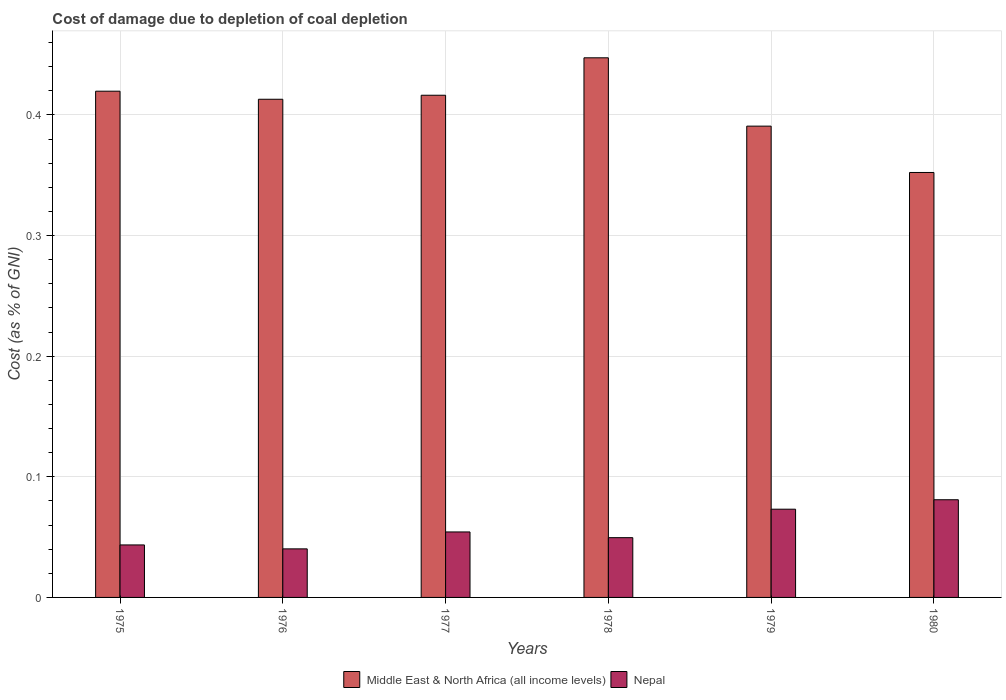Are the number of bars on each tick of the X-axis equal?
Your response must be concise. Yes. How many bars are there on the 3rd tick from the right?
Make the answer very short. 2. What is the label of the 2nd group of bars from the left?
Your answer should be very brief. 1976. What is the cost of damage caused due to coal depletion in Nepal in 1978?
Give a very brief answer. 0.05. Across all years, what is the maximum cost of damage caused due to coal depletion in Middle East & North Africa (all income levels)?
Keep it short and to the point. 0.45. Across all years, what is the minimum cost of damage caused due to coal depletion in Middle East & North Africa (all income levels)?
Your answer should be compact. 0.35. In which year was the cost of damage caused due to coal depletion in Middle East & North Africa (all income levels) maximum?
Ensure brevity in your answer.  1978. What is the total cost of damage caused due to coal depletion in Nepal in the graph?
Provide a short and direct response. 0.34. What is the difference between the cost of damage caused due to coal depletion in Middle East & North Africa (all income levels) in 1978 and that in 1979?
Ensure brevity in your answer.  0.06. What is the difference between the cost of damage caused due to coal depletion in Nepal in 1975 and the cost of damage caused due to coal depletion in Middle East & North Africa (all income levels) in 1978?
Your answer should be very brief. -0.4. What is the average cost of damage caused due to coal depletion in Nepal per year?
Your answer should be very brief. 0.06. In the year 1979, what is the difference between the cost of damage caused due to coal depletion in Middle East & North Africa (all income levels) and cost of damage caused due to coal depletion in Nepal?
Your response must be concise. 0.32. In how many years, is the cost of damage caused due to coal depletion in Middle East & North Africa (all income levels) greater than 0.24000000000000002 %?
Your answer should be very brief. 6. What is the ratio of the cost of damage caused due to coal depletion in Middle East & North Africa (all income levels) in 1975 to that in 1980?
Your answer should be very brief. 1.19. Is the cost of damage caused due to coal depletion in Nepal in 1976 less than that in 1977?
Your answer should be compact. Yes. Is the difference between the cost of damage caused due to coal depletion in Middle East & North Africa (all income levels) in 1977 and 1980 greater than the difference between the cost of damage caused due to coal depletion in Nepal in 1977 and 1980?
Provide a short and direct response. Yes. What is the difference between the highest and the second highest cost of damage caused due to coal depletion in Middle East & North Africa (all income levels)?
Give a very brief answer. 0.03. What is the difference between the highest and the lowest cost of damage caused due to coal depletion in Nepal?
Keep it short and to the point. 0.04. Is the sum of the cost of damage caused due to coal depletion in Middle East & North Africa (all income levels) in 1976 and 1978 greater than the maximum cost of damage caused due to coal depletion in Nepal across all years?
Offer a terse response. Yes. What does the 1st bar from the left in 1977 represents?
Make the answer very short. Middle East & North Africa (all income levels). What does the 1st bar from the right in 1977 represents?
Provide a short and direct response. Nepal. How many bars are there?
Your answer should be very brief. 12. Are all the bars in the graph horizontal?
Make the answer very short. No. How many years are there in the graph?
Ensure brevity in your answer.  6. Does the graph contain any zero values?
Your answer should be compact. No. Where does the legend appear in the graph?
Your answer should be very brief. Bottom center. How many legend labels are there?
Offer a terse response. 2. How are the legend labels stacked?
Offer a very short reply. Horizontal. What is the title of the graph?
Keep it short and to the point. Cost of damage due to depletion of coal depletion. What is the label or title of the X-axis?
Keep it short and to the point. Years. What is the label or title of the Y-axis?
Offer a terse response. Cost (as % of GNI). What is the Cost (as % of GNI) of Middle East & North Africa (all income levels) in 1975?
Give a very brief answer. 0.42. What is the Cost (as % of GNI) of Nepal in 1975?
Your answer should be very brief. 0.04. What is the Cost (as % of GNI) in Middle East & North Africa (all income levels) in 1976?
Your response must be concise. 0.41. What is the Cost (as % of GNI) in Nepal in 1976?
Your answer should be compact. 0.04. What is the Cost (as % of GNI) of Middle East & North Africa (all income levels) in 1977?
Your response must be concise. 0.42. What is the Cost (as % of GNI) of Nepal in 1977?
Give a very brief answer. 0.05. What is the Cost (as % of GNI) in Middle East & North Africa (all income levels) in 1978?
Your response must be concise. 0.45. What is the Cost (as % of GNI) in Nepal in 1978?
Offer a terse response. 0.05. What is the Cost (as % of GNI) of Middle East & North Africa (all income levels) in 1979?
Give a very brief answer. 0.39. What is the Cost (as % of GNI) of Nepal in 1979?
Offer a terse response. 0.07. What is the Cost (as % of GNI) of Middle East & North Africa (all income levels) in 1980?
Your response must be concise. 0.35. What is the Cost (as % of GNI) in Nepal in 1980?
Give a very brief answer. 0.08. Across all years, what is the maximum Cost (as % of GNI) of Middle East & North Africa (all income levels)?
Give a very brief answer. 0.45. Across all years, what is the maximum Cost (as % of GNI) of Nepal?
Provide a succinct answer. 0.08. Across all years, what is the minimum Cost (as % of GNI) in Middle East & North Africa (all income levels)?
Provide a short and direct response. 0.35. Across all years, what is the minimum Cost (as % of GNI) of Nepal?
Provide a short and direct response. 0.04. What is the total Cost (as % of GNI) in Middle East & North Africa (all income levels) in the graph?
Make the answer very short. 2.44. What is the total Cost (as % of GNI) in Nepal in the graph?
Your response must be concise. 0.34. What is the difference between the Cost (as % of GNI) of Middle East & North Africa (all income levels) in 1975 and that in 1976?
Give a very brief answer. 0.01. What is the difference between the Cost (as % of GNI) of Nepal in 1975 and that in 1976?
Give a very brief answer. 0. What is the difference between the Cost (as % of GNI) in Middle East & North Africa (all income levels) in 1975 and that in 1977?
Your answer should be compact. 0. What is the difference between the Cost (as % of GNI) in Nepal in 1975 and that in 1977?
Your response must be concise. -0.01. What is the difference between the Cost (as % of GNI) of Middle East & North Africa (all income levels) in 1975 and that in 1978?
Offer a terse response. -0.03. What is the difference between the Cost (as % of GNI) of Nepal in 1975 and that in 1978?
Offer a terse response. -0.01. What is the difference between the Cost (as % of GNI) in Middle East & North Africa (all income levels) in 1975 and that in 1979?
Your answer should be very brief. 0.03. What is the difference between the Cost (as % of GNI) in Nepal in 1975 and that in 1979?
Make the answer very short. -0.03. What is the difference between the Cost (as % of GNI) in Middle East & North Africa (all income levels) in 1975 and that in 1980?
Provide a succinct answer. 0.07. What is the difference between the Cost (as % of GNI) in Nepal in 1975 and that in 1980?
Your response must be concise. -0.04. What is the difference between the Cost (as % of GNI) of Middle East & North Africa (all income levels) in 1976 and that in 1977?
Ensure brevity in your answer.  -0. What is the difference between the Cost (as % of GNI) in Nepal in 1976 and that in 1977?
Provide a short and direct response. -0.01. What is the difference between the Cost (as % of GNI) of Middle East & North Africa (all income levels) in 1976 and that in 1978?
Ensure brevity in your answer.  -0.03. What is the difference between the Cost (as % of GNI) of Nepal in 1976 and that in 1978?
Give a very brief answer. -0.01. What is the difference between the Cost (as % of GNI) in Middle East & North Africa (all income levels) in 1976 and that in 1979?
Your answer should be very brief. 0.02. What is the difference between the Cost (as % of GNI) of Nepal in 1976 and that in 1979?
Your answer should be compact. -0.03. What is the difference between the Cost (as % of GNI) of Middle East & North Africa (all income levels) in 1976 and that in 1980?
Provide a succinct answer. 0.06. What is the difference between the Cost (as % of GNI) of Nepal in 1976 and that in 1980?
Offer a terse response. -0.04. What is the difference between the Cost (as % of GNI) of Middle East & North Africa (all income levels) in 1977 and that in 1978?
Your answer should be compact. -0.03. What is the difference between the Cost (as % of GNI) in Nepal in 1977 and that in 1978?
Your answer should be very brief. 0. What is the difference between the Cost (as % of GNI) in Middle East & North Africa (all income levels) in 1977 and that in 1979?
Provide a short and direct response. 0.03. What is the difference between the Cost (as % of GNI) in Nepal in 1977 and that in 1979?
Ensure brevity in your answer.  -0.02. What is the difference between the Cost (as % of GNI) in Middle East & North Africa (all income levels) in 1977 and that in 1980?
Ensure brevity in your answer.  0.06. What is the difference between the Cost (as % of GNI) of Nepal in 1977 and that in 1980?
Offer a terse response. -0.03. What is the difference between the Cost (as % of GNI) in Middle East & North Africa (all income levels) in 1978 and that in 1979?
Offer a very short reply. 0.06. What is the difference between the Cost (as % of GNI) in Nepal in 1978 and that in 1979?
Give a very brief answer. -0.02. What is the difference between the Cost (as % of GNI) of Middle East & North Africa (all income levels) in 1978 and that in 1980?
Offer a terse response. 0.1. What is the difference between the Cost (as % of GNI) in Nepal in 1978 and that in 1980?
Your answer should be very brief. -0.03. What is the difference between the Cost (as % of GNI) of Middle East & North Africa (all income levels) in 1979 and that in 1980?
Make the answer very short. 0.04. What is the difference between the Cost (as % of GNI) of Nepal in 1979 and that in 1980?
Provide a succinct answer. -0.01. What is the difference between the Cost (as % of GNI) in Middle East & North Africa (all income levels) in 1975 and the Cost (as % of GNI) in Nepal in 1976?
Offer a very short reply. 0.38. What is the difference between the Cost (as % of GNI) of Middle East & North Africa (all income levels) in 1975 and the Cost (as % of GNI) of Nepal in 1977?
Offer a very short reply. 0.37. What is the difference between the Cost (as % of GNI) of Middle East & North Africa (all income levels) in 1975 and the Cost (as % of GNI) of Nepal in 1978?
Give a very brief answer. 0.37. What is the difference between the Cost (as % of GNI) of Middle East & North Africa (all income levels) in 1975 and the Cost (as % of GNI) of Nepal in 1979?
Keep it short and to the point. 0.35. What is the difference between the Cost (as % of GNI) of Middle East & North Africa (all income levels) in 1975 and the Cost (as % of GNI) of Nepal in 1980?
Provide a succinct answer. 0.34. What is the difference between the Cost (as % of GNI) in Middle East & North Africa (all income levels) in 1976 and the Cost (as % of GNI) in Nepal in 1977?
Make the answer very short. 0.36. What is the difference between the Cost (as % of GNI) in Middle East & North Africa (all income levels) in 1976 and the Cost (as % of GNI) in Nepal in 1978?
Your answer should be compact. 0.36. What is the difference between the Cost (as % of GNI) in Middle East & North Africa (all income levels) in 1976 and the Cost (as % of GNI) in Nepal in 1979?
Keep it short and to the point. 0.34. What is the difference between the Cost (as % of GNI) of Middle East & North Africa (all income levels) in 1976 and the Cost (as % of GNI) of Nepal in 1980?
Offer a very short reply. 0.33. What is the difference between the Cost (as % of GNI) in Middle East & North Africa (all income levels) in 1977 and the Cost (as % of GNI) in Nepal in 1978?
Make the answer very short. 0.37. What is the difference between the Cost (as % of GNI) of Middle East & North Africa (all income levels) in 1977 and the Cost (as % of GNI) of Nepal in 1979?
Give a very brief answer. 0.34. What is the difference between the Cost (as % of GNI) of Middle East & North Africa (all income levels) in 1977 and the Cost (as % of GNI) of Nepal in 1980?
Ensure brevity in your answer.  0.34. What is the difference between the Cost (as % of GNI) in Middle East & North Africa (all income levels) in 1978 and the Cost (as % of GNI) in Nepal in 1979?
Make the answer very short. 0.37. What is the difference between the Cost (as % of GNI) of Middle East & North Africa (all income levels) in 1978 and the Cost (as % of GNI) of Nepal in 1980?
Provide a succinct answer. 0.37. What is the difference between the Cost (as % of GNI) in Middle East & North Africa (all income levels) in 1979 and the Cost (as % of GNI) in Nepal in 1980?
Your answer should be very brief. 0.31. What is the average Cost (as % of GNI) of Middle East & North Africa (all income levels) per year?
Provide a succinct answer. 0.41. What is the average Cost (as % of GNI) of Nepal per year?
Your response must be concise. 0.06. In the year 1975, what is the difference between the Cost (as % of GNI) of Middle East & North Africa (all income levels) and Cost (as % of GNI) of Nepal?
Make the answer very short. 0.38. In the year 1976, what is the difference between the Cost (as % of GNI) in Middle East & North Africa (all income levels) and Cost (as % of GNI) in Nepal?
Provide a short and direct response. 0.37. In the year 1977, what is the difference between the Cost (as % of GNI) of Middle East & North Africa (all income levels) and Cost (as % of GNI) of Nepal?
Provide a short and direct response. 0.36. In the year 1978, what is the difference between the Cost (as % of GNI) in Middle East & North Africa (all income levels) and Cost (as % of GNI) in Nepal?
Provide a short and direct response. 0.4. In the year 1979, what is the difference between the Cost (as % of GNI) in Middle East & North Africa (all income levels) and Cost (as % of GNI) in Nepal?
Give a very brief answer. 0.32. In the year 1980, what is the difference between the Cost (as % of GNI) of Middle East & North Africa (all income levels) and Cost (as % of GNI) of Nepal?
Offer a terse response. 0.27. What is the ratio of the Cost (as % of GNI) of Middle East & North Africa (all income levels) in 1975 to that in 1976?
Your response must be concise. 1.02. What is the ratio of the Cost (as % of GNI) of Nepal in 1975 to that in 1976?
Offer a very short reply. 1.08. What is the ratio of the Cost (as % of GNI) of Middle East & North Africa (all income levels) in 1975 to that in 1977?
Your answer should be very brief. 1.01. What is the ratio of the Cost (as % of GNI) of Nepal in 1975 to that in 1977?
Give a very brief answer. 0.8. What is the ratio of the Cost (as % of GNI) in Middle East & North Africa (all income levels) in 1975 to that in 1978?
Provide a succinct answer. 0.94. What is the ratio of the Cost (as % of GNI) of Nepal in 1975 to that in 1978?
Keep it short and to the point. 0.88. What is the ratio of the Cost (as % of GNI) in Middle East & North Africa (all income levels) in 1975 to that in 1979?
Offer a very short reply. 1.07. What is the ratio of the Cost (as % of GNI) of Nepal in 1975 to that in 1979?
Provide a succinct answer. 0.59. What is the ratio of the Cost (as % of GNI) of Middle East & North Africa (all income levels) in 1975 to that in 1980?
Your response must be concise. 1.19. What is the ratio of the Cost (as % of GNI) of Nepal in 1975 to that in 1980?
Your answer should be very brief. 0.54. What is the ratio of the Cost (as % of GNI) in Middle East & North Africa (all income levels) in 1976 to that in 1977?
Your answer should be compact. 0.99. What is the ratio of the Cost (as % of GNI) of Nepal in 1976 to that in 1977?
Offer a very short reply. 0.74. What is the ratio of the Cost (as % of GNI) in Middle East & North Africa (all income levels) in 1976 to that in 1978?
Offer a very short reply. 0.92. What is the ratio of the Cost (as % of GNI) in Nepal in 1976 to that in 1978?
Give a very brief answer. 0.81. What is the ratio of the Cost (as % of GNI) of Middle East & North Africa (all income levels) in 1976 to that in 1979?
Give a very brief answer. 1.06. What is the ratio of the Cost (as % of GNI) in Nepal in 1976 to that in 1979?
Provide a short and direct response. 0.55. What is the ratio of the Cost (as % of GNI) of Middle East & North Africa (all income levels) in 1976 to that in 1980?
Give a very brief answer. 1.17. What is the ratio of the Cost (as % of GNI) in Nepal in 1976 to that in 1980?
Give a very brief answer. 0.5. What is the ratio of the Cost (as % of GNI) in Middle East & North Africa (all income levels) in 1977 to that in 1978?
Make the answer very short. 0.93. What is the ratio of the Cost (as % of GNI) in Nepal in 1977 to that in 1978?
Give a very brief answer. 1.1. What is the ratio of the Cost (as % of GNI) in Middle East & North Africa (all income levels) in 1977 to that in 1979?
Make the answer very short. 1.07. What is the ratio of the Cost (as % of GNI) in Nepal in 1977 to that in 1979?
Offer a very short reply. 0.74. What is the ratio of the Cost (as % of GNI) of Middle East & North Africa (all income levels) in 1977 to that in 1980?
Your answer should be compact. 1.18. What is the ratio of the Cost (as % of GNI) of Nepal in 1977 to that in 1980?
Provide a succinct answer. 0.67. What is the ratio of the Cost (as % of GNI) in Middle East & North Africa (all income levels) in 1978 to that in 1979?
Provide a short and direct response. 1.15. What is the ratio of the Cost (as % of GNI) in Nepal in 1978 to that in 1979?
Your response must be concise. 0.68. What is the ratio of the Cost (as % of GNI) in Middle East & North Africa (all income levels) in 1978 to that in 1980?
Your answer should be very brief. 1.27. What is the ratio of the Cost (as % of GNI) in Nepal in 1978 to that in 1980?
Give a very brief answer. 0.61. What is the ratio of the Cost (as % of GNI) in Middle East & North Africa (all income levels) in 1979 to that in 1980?
Your answer should be very brief. 1.11. What is the ratio of the Cost (as % of GNI) of Nepal in 1979 to that in 1980?
Provide a short and direct response. 0.9. What is the difference between the highest and the second highest Cost (as % of GNI) in Middle East & North Africa (all income levels)?
Your response must be concise. 0.03. What is the difference between the highest and the second highest Cost (as % of GNI) of Nepal?
Your answer should be compact. 0.01. What is the difference between the highest and the lowest Cost (as % of GNI) in Middle East & North Africa (all income levels)?
Offer a terse response. 0.1. What is the difference between the highest and the lowest Cost (as % of GNI) of Nepal?
Provide a succinct answer. 0.04. 